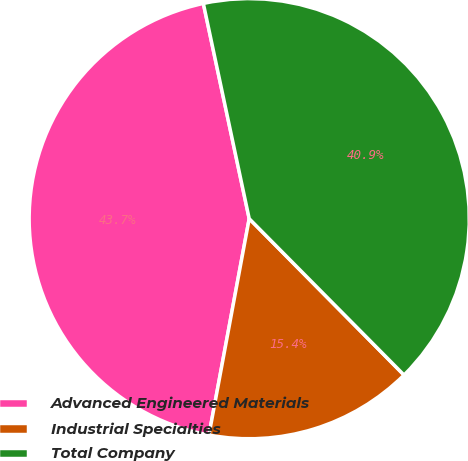Convert chart. <chart><loc_0><loc_0><loc_500><loc_500><pie_chart><fcel>Advanced Engineered Materials<fcel>Industrial Specialties<fcel>Total Company<nl><fcel>43.73%<fcel>15.35%<fcel>40.92%<nl></chart> 